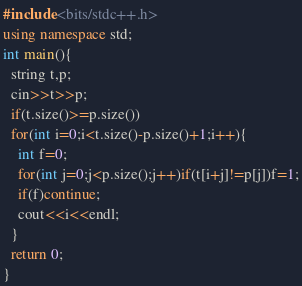Convert code to text. <code><loc_0><loc_0><loc_500><loc_500><_C++_>#include<bits/stdc++.h>
using namespace std;
int main(){
  string t,p;
  cin>>t>>p;
  if(t.size()>=p.size())
  for(int i=0;i<t.size()-p.size()+1;i++){
    int f=0;
    for(int j=0;j<p.size();j++)if(t[i+j]!=p[j])f=1;
    if(f)continue;
    cout<<i<<endl;
  }
  return 0;
}</code> 